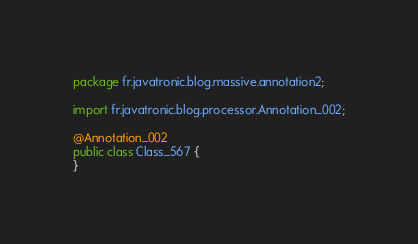<code> <loc_0><loc_0><loc_500><loc_500><_Java_>package fr.javatronic.blog.massive.annotation2;

import fr.javatronic.blog.processor.Annotation_002;

@Annotation_002
public class Class_567 {
}
</code> 